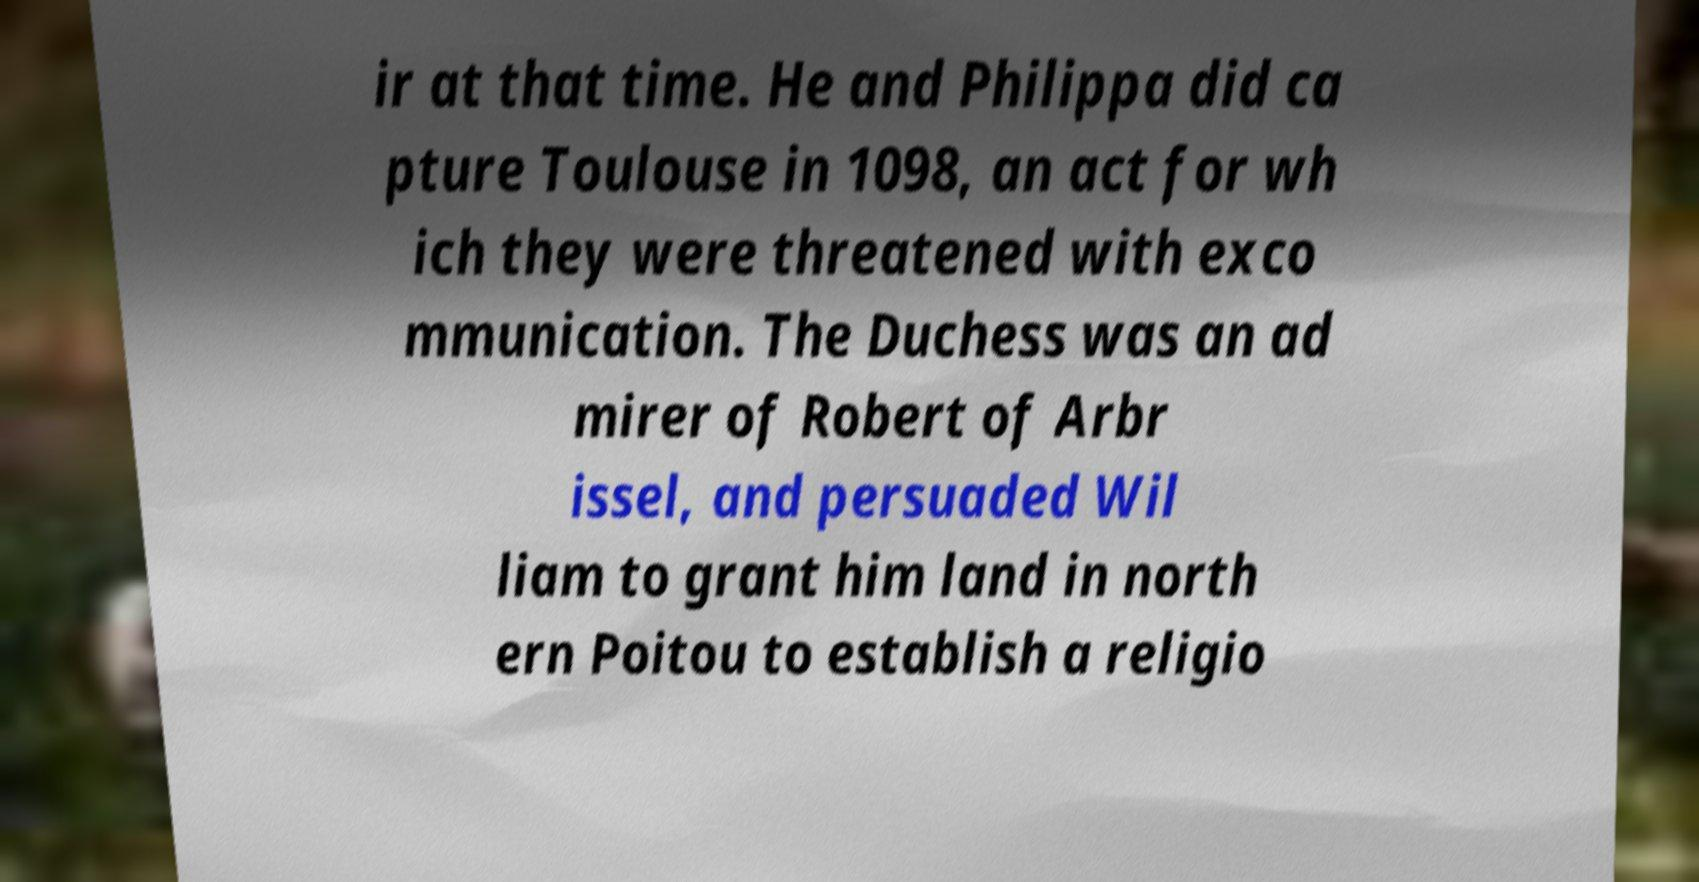Please read and relay the text visible in this image. What does it say? ir at that time. He and Philippa did ca pture Toulouse in 1098, an act for wh ich they were threatened with exco mmunication. The Duchess was an ad mirer of Robert of Arbr issel, and persuaded Wil liam to grant him land in north ern Poitou to establish a religio 